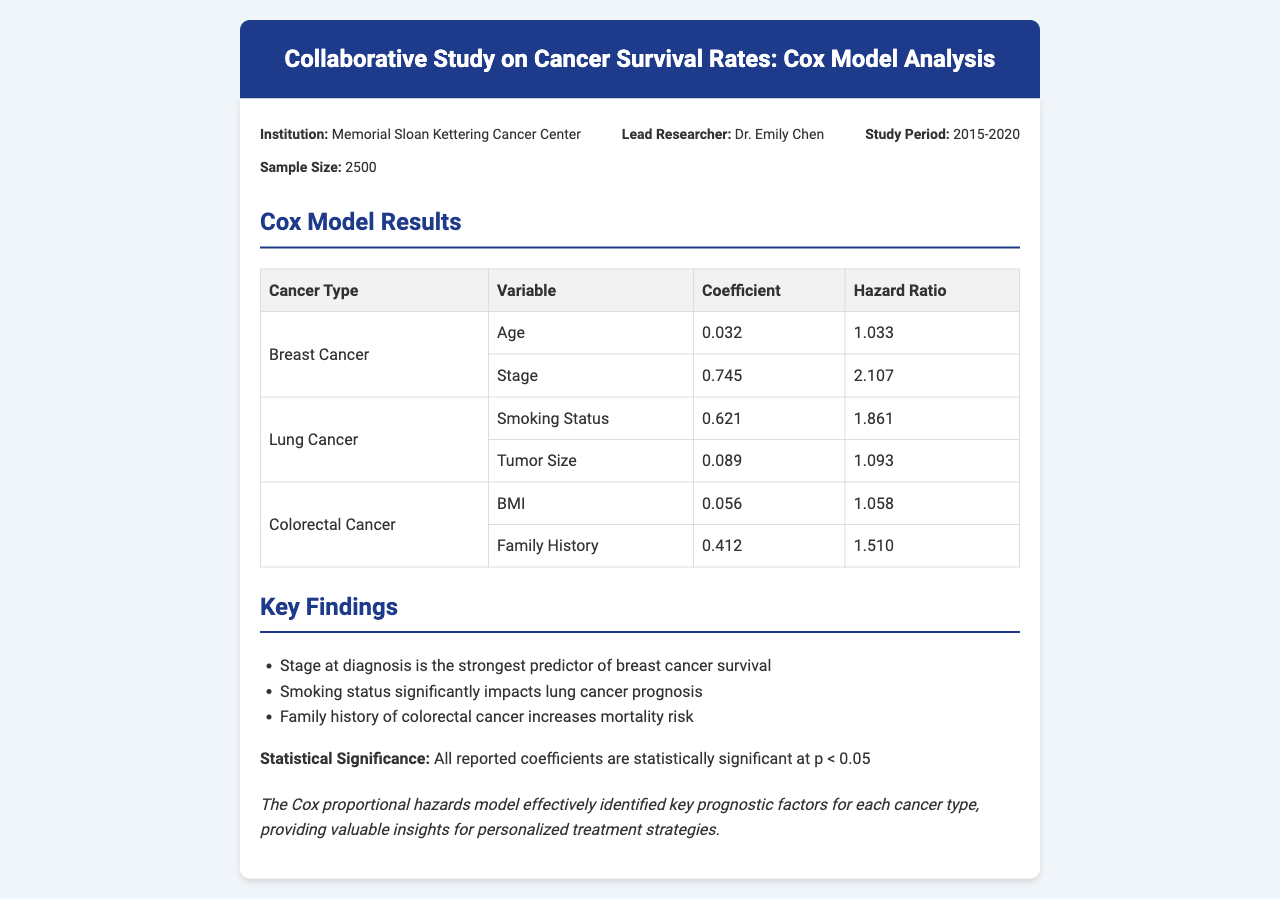What is the lead researcher's name? The lead researcher's name is listed in the study details section of the document.
Answer: Dr. Emily Chen What was the sample size of the study? The sample size is provided in the study details section of the document.
Answer: 2500 What is the hazard ratio for Stage in Breast Cancer? The hazard ratio for Stage in Breast Cancer is found in the Cox model results table.
Answer: 2.107 Which cancer type has the strongest predictor for survival? This information is available under the key findings section of the document.
Answer: Breast Cancer What is the statistical significance level reported? The document specifies a significance level related to the coefficients in the study.
Answer: p < 0.05 How long was the study period? The study period is detailed in the study details section of the document.
Answer: 2015-2020 What variable is associated with the coefficient of 0.412 in Colorectal Cancer? The variable associated with this coefficient can be found in the Cox model results table.
Answer: Family History Which factor significantly impacts lung cancer prognosis? The key findings section outlines significant factors for lung cancer survival.
Answer: Smoking Status What institution conducted the study? The institution's name is provided at the beginning of the document in the study details section.
Answer: Memorial Sloan Kettering Cancer Center 